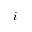<formula> <loc_0><loc_0><loc_500><loc_500>i</formula> 